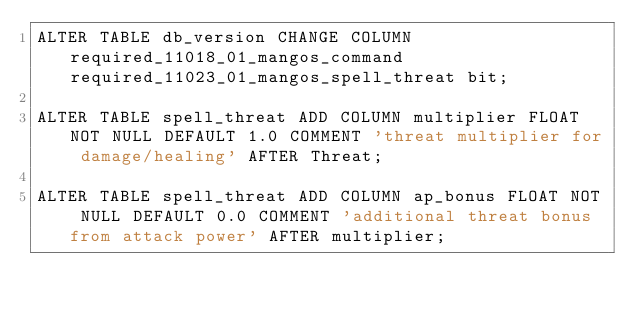Convert code to text. <code><loc_0><loc_0><loc_500><loc_500><_SQL_>ALTER TABLE db_version CHANGE COLUMN required_11018_01_mangos_command required_11023_01_mangos_spell_threat bit;

ALTER TABLE spell_threat ADD COLUMN multiplier FLOAT NOT NULL DEFAULT 1.0 COMMENT 'threat multiplier for damage/healing' AFTER Threat;

ALTER TABLE spell_threat ADD COLUMN ap_bonus FLOAT NOT NULL DEFAULT 0.0 COMMENT 'additional threat bonus from attack power' AFTER multiplier;
</code> 